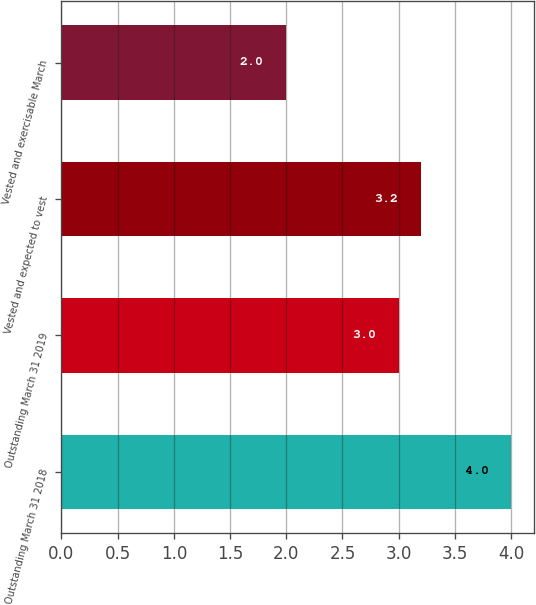<chart> <loc_0><loc_0><loc_500><loc_500><bar_chart><fcel>Outstanding March 31 2018<fcel>Outstanding March 31 2019<fcel>Vested and expected to vest<fcel>Vested and exercisable March<nl><fcel>4<fcel>3<fcel>3.2<fcel>2<nl></chart> 